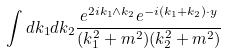Convert formula to latex. <formula><loc_0><loc_0><loc_500><loc_500>\int d k _ { 1 } d k _ { 2 } \frac { e ^ { 2 i k _ { 1 } \wedge k _ { 2 } } e ^ { - i ( k _ { 1 } + k _ { 2 } ) \cdot y } } { ( k _ { 1 } ^ { 2 } + m ^ { 2 } ) ( k _ { 2 } ^ { 2 } + m ^ { 2 } ) }</formula> 